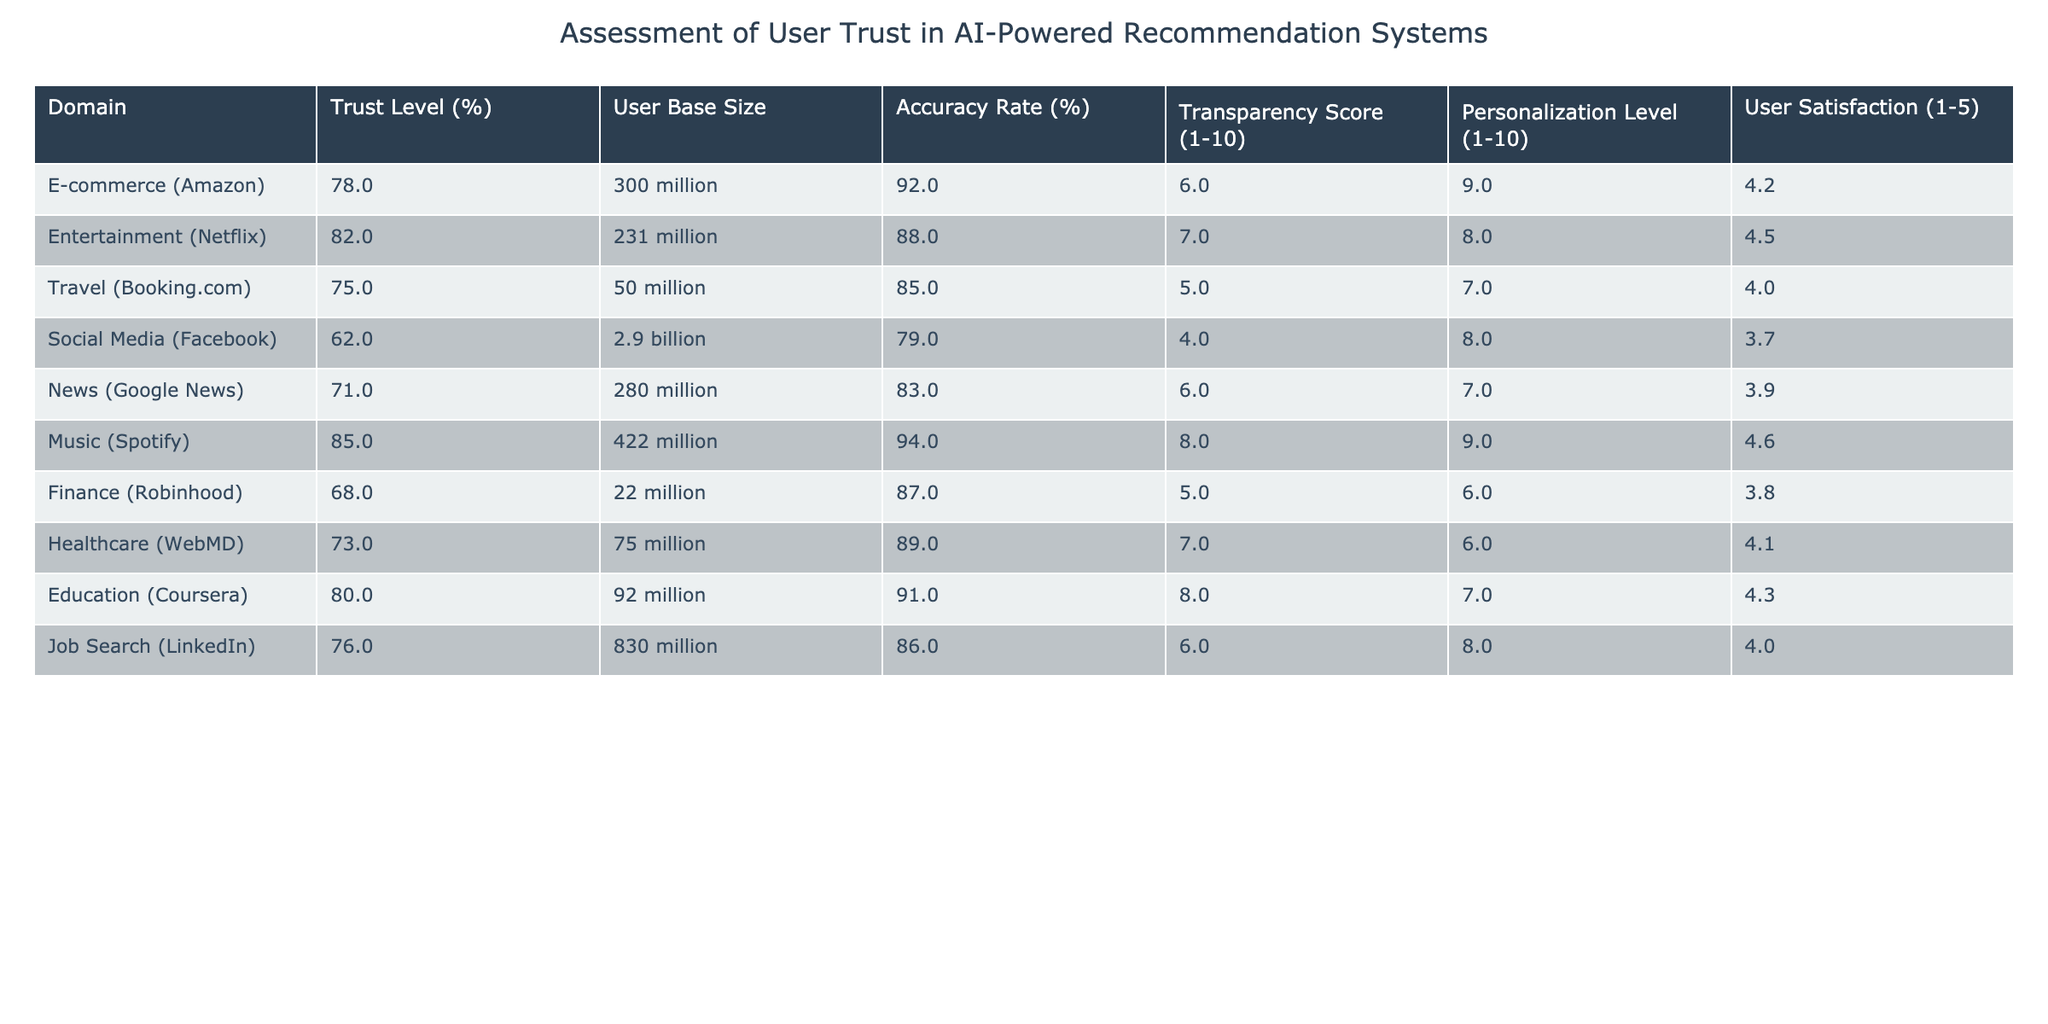What is the trust level for the E-commerce domain? The table lists the trust level for E-commerce (Amazon) as 78%.
Answer: 78% Which domain has the highest personalization level? Looking at the table, Music (Spotify) has a personalization level of 9, which is higher than all other domains listed.
Answer: Music (Spotify) Is the accuracy rate higher for E-commerce or Social Media? The accuracy rate for E-commerce (Amazon) is 92%, while for Social Media (Facebook) it is 79%. Therefore, E-commerce has a higher accuracy rate.
Answer: Yes What is the average trust level across the listed domains? To find the average, we sum all trust levels: (78 + 82 + 75 + 62 + 71 + 85 + 68 + 73 + 80 + 76) =  76.8. There are 10 domains, so the average trust level is 768/10 = 76.8.
Answer: 76.8 Does the travel domain have a higher transparency score than the finance domain? The transparency score for Travel (Booking.com) is 5, whereas for Finance (Robinhood), it is 5 as well. Both are equal, meaning neither has a higher score.
Answer: No Which two domains have a user satisfaction rating of 4.0? By examining the table, we can identify that Travel (Booking.com) and Job Search (LinkedIn) both have a user satisfaction rating of 4.0.
Answer: Travel (Booking.com) and Job Search (LinkedIn) Is the user base size for Music (Spotify) greater than that for Finance (Robinhood)? User base size for Music (Spotify) is listed as 422 million, whereas the user base size for Finance (Robinhood) is just 22 million. Therefore, Music has a significantly larger user base.
Answer: Yes What domain has the lowest user satisfaction score? Upon reviewing the table, Social Media (Facebook) has the lowest user satisfaction score at 3.7 compared to all other domains.
Answer: Social Media (Facebook) If we sum the transparency scores of all domains, what is the result? Adding up all transparency scores (6 + 7 + 5 + 4 + 6 + 8 + 5 + 7 + 8 + 6) gives us 62.
Answer: 62 